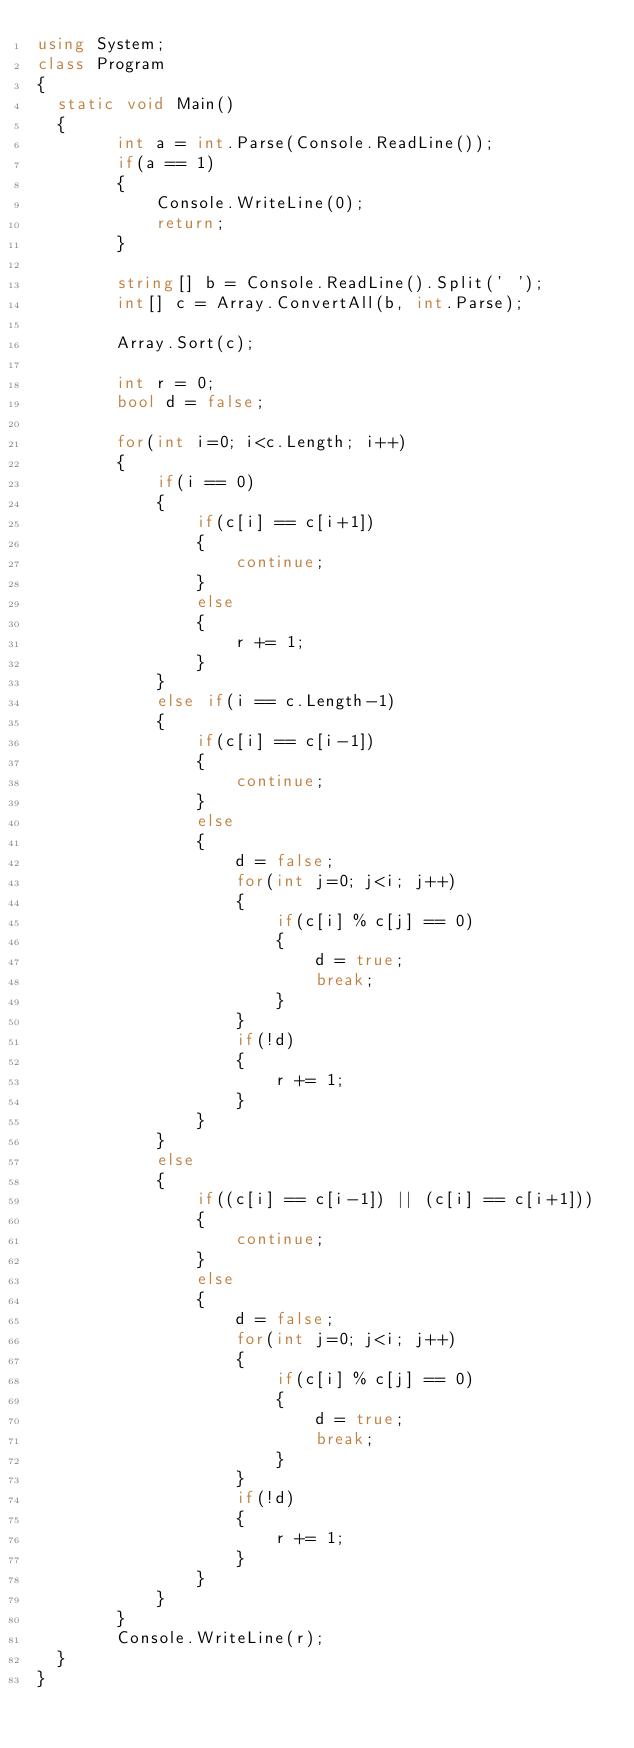<code> <loc_0><loc_0><loc_500><loc_500><_C#_>using System;
class Program
{
	static void Main()
	{
        int a = int.Parse(Console.ReadLine());
        if(a == 1)
        {
            Console.WriteLine(0);
            return;
        }

        string[] b = Console.ReadLine().Split(' ');
        int[] c = Array.ConvertAll(b, int.Parse);

        Array.Sort(c);

        int r = 0;
        bool d = false;

        for(int i=0; i<c.Length; i++)
        {
            if(i == 0)
            {
                if(c[i] == c[i+1])
                {
                    continue;
                }
                else
                {
                    r += 1;
                }
            }
            else if(i == c.Length-1)
            {
                if(c[i] == c[i-1])
                {
                    continue;
                }
                else
                {
                    d = false;
                    for(int j=0; j<i; j++)
                    {
                        if(c[i] % c[j] == 0)
                        {
                            d = true;
                            break;
                        }
                    }
                    if(!d)
                    {
                        r += 1;
                    }
                }
            }
            else
            {
                if((c[i] == c[i-1]) || (c[i] == c[i+1]))
                {
                    continue;
                }
                else
                {
                    d = false;
                    for(int j=0; j<i; j++)
                    {
                        if(c[i] % c[j] == 0)
                        {
                            d = true;
                            break;
                        }
                    }
                    if(!d)
                    {
                        r += 1;
                    }
                }
            }
        }
        Console.WriteLine(r);
	}
}</code> 